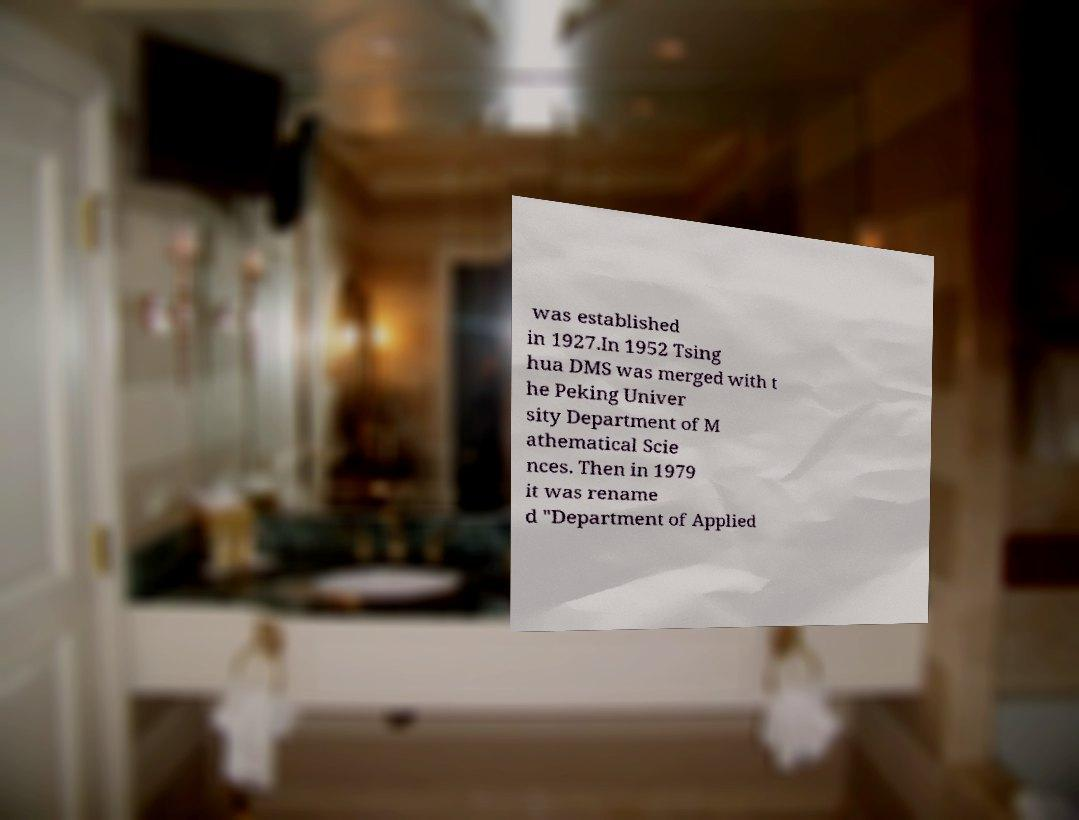Could you extract and type out the text from this image? was established in 1927.In 1952 Tsing hua DMS was merged with t he Peking Univer sity Department of M athematical Scie nces. Then in 1979 it was rename d "Department of Applied 